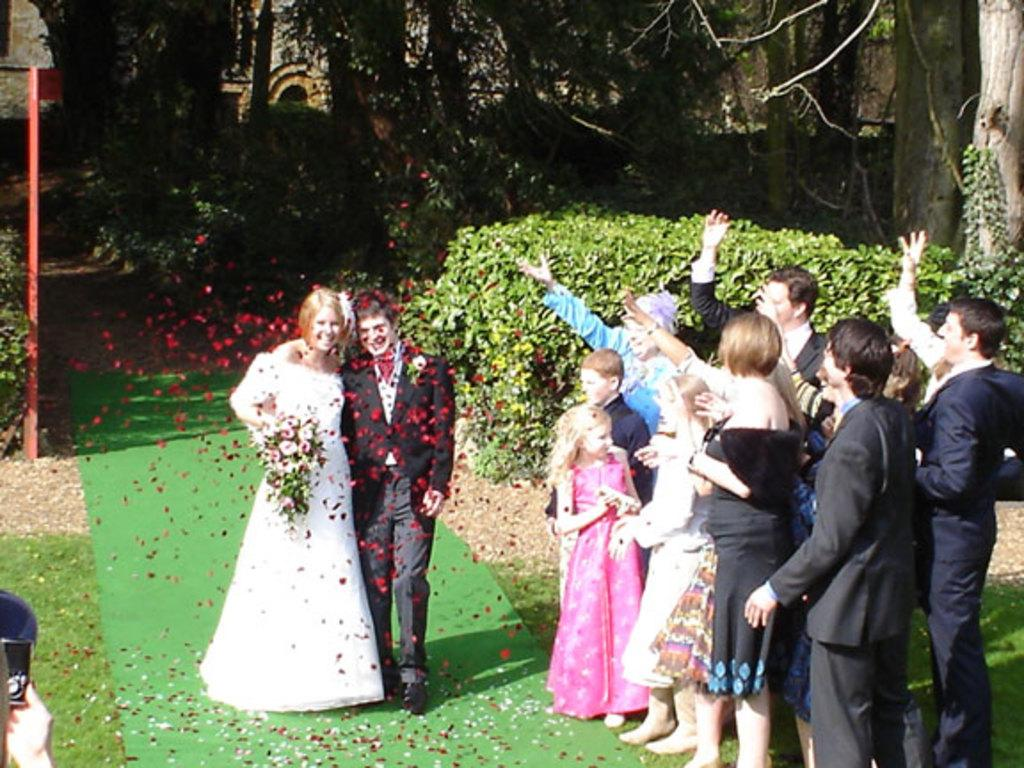What are the couple in the image doing? The couple in the image is walking. What is the surface they are walking on? The couple is walking on a green mat. Are there any other people present in the image? Yes, there are people standing beside the couple. What can be seen in the background of the image? There are plants and trees in the background of the image. How many eyes can be seen on the couple's finger in the image? There are no eyes or fingers mentioned in the image; it only shows a couple walking on a green mat with people standing beside them and plants and trees in the background. 